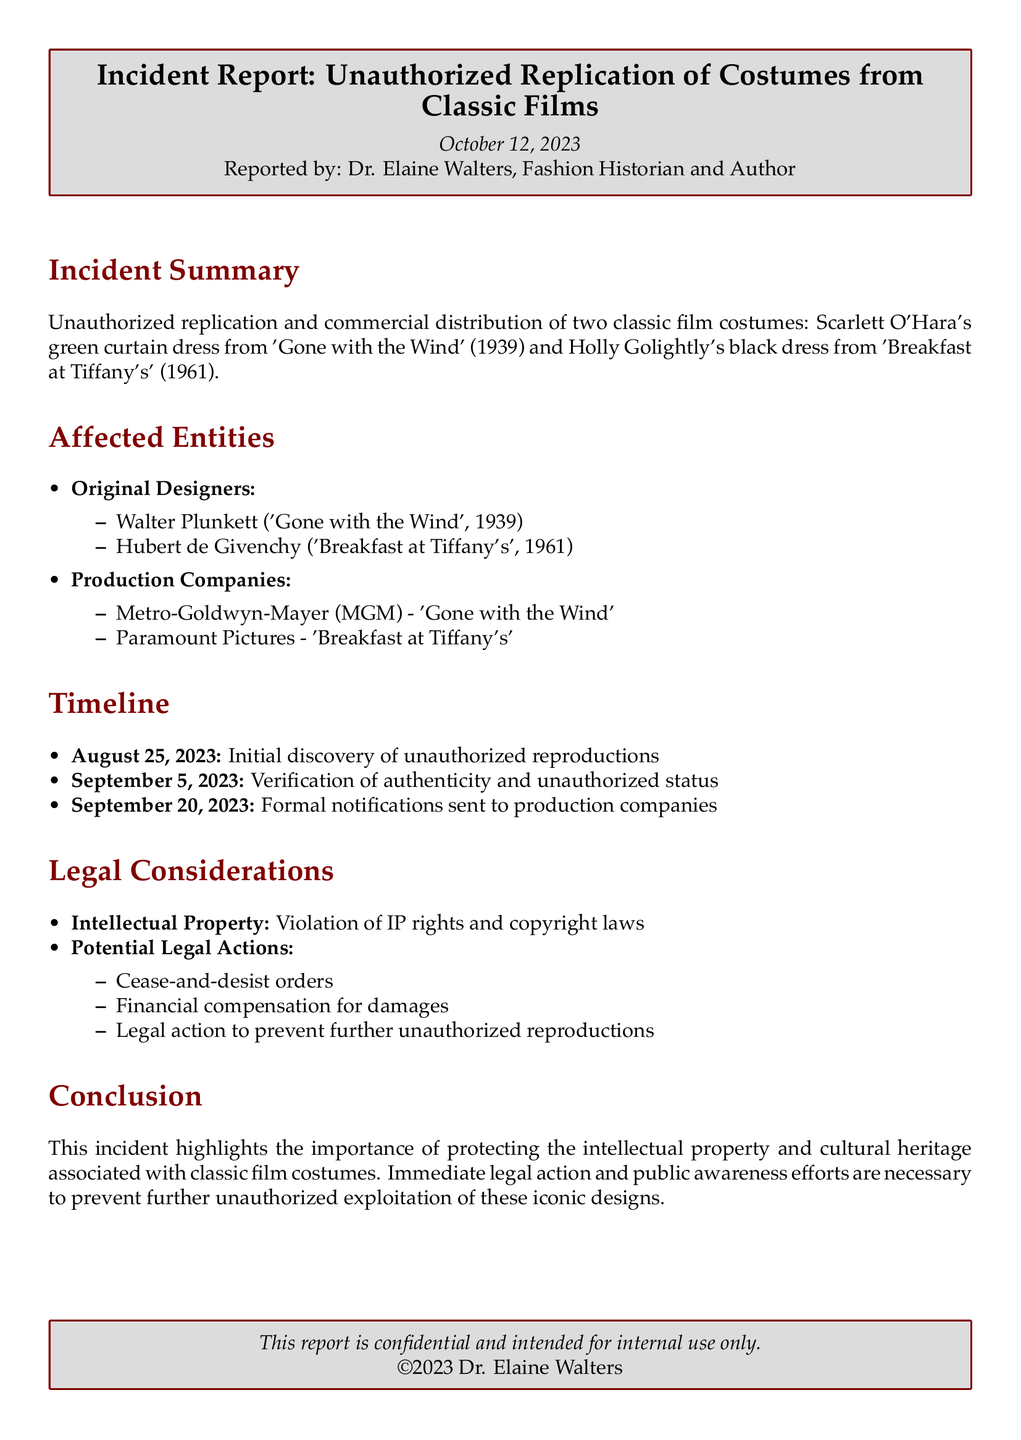What is the date of the incident report? The date is stated at the beginning of the document, which is October 12, 2023.
Answer: October 12, 2023 Who reported the incident? The report mentions that it was reported by Dr. Elaine Walters.
Answer: Dr. Elaine Walters What are the names of the original designers of the costumes? The document lists two original designers: Walter Plunkett and Hubert de Givenchy.
Answer: Walter Plunkett, Hubert de Givenchy When was the initial discovery of the unauthorized reproductions? The timeline in the document specifies the date of initial discovery as August 25, 2023.
Answer: August 25, 2023 What type of legal actions are considered in the report? The report indicates potential legal actions such as cease-and-desist orders and financial compensation for damages.
Answer: Cease-and-desist orders What movies are associated with the unauthorized costume replicas? The summary section details two films: 'Gone with the Wind' and 'Breakfast at Tiffany's.'
Answer: 'Gone with the Wind', 'Breakfast at Tiffany's' What is the purpose of the report? The conclusion states that the report aims to emphasize the importance of protecting intellectual property and cultural heritage.
Answer: To protect intellectual property and cultural heritage What is the color of the main theme used in the document? The document describes the main color used as RGB (128,0,0).
Answer: RGB (128,0,0) 